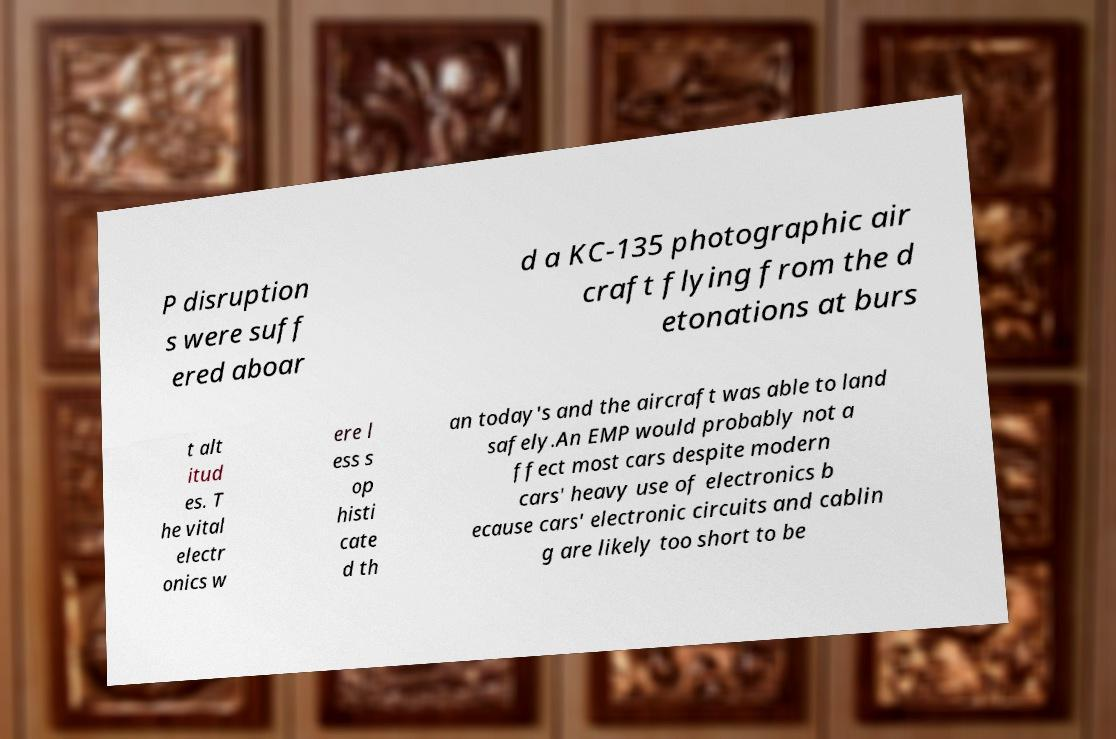I need the written content from this picture converted into text. Can you do that? P disruption s were suff ered aboar d a KC-135 photographic air craft flying from the d etonations at burs t alt itud es. T he vital electr onics w ere l ess s op histi cate d th an today's and the aircraft was able to land safely.An EMP would probably not a ffect most cars despite modern cars' heavy use of electronics b ecause cars' electronic circuits and cablin g are likely too short to be 